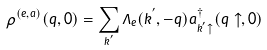<formula> <loc_0><loc_0><loc_500><loc_500>\rho ^ { ( e , a ) } ( { q } , 0 ) = \sum _ { { k } ^ { ^ { \prime } } } \Lambda _ { e } ( { k } ^ { ^ { \prime } } , - { q } ) a ^ { \dagger } _ { { k } ^ { ^ { \prime } } \uparrow } ( { q } \uparrow , 0 )</formula> 